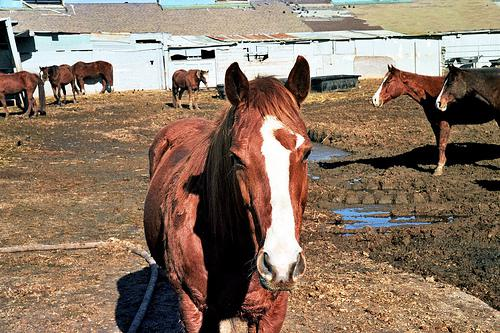Question: what is this a photo of?
Choices:
A. Horses.
B. Cows.
C. Donkeys.
D. Zebras.
Answer with the letter. Answer: A Question: why is there mud?
Choices:
A. It rained.
B. The dirt is wet.
C. There is no grass.
D. The animals scratched the ground.
Answer with the letter. Answer: A Question: who rides a horse?
Choices:
A. A man.
B. A woman.
C. A farmer.
D. A cowboy.
Answer with the letter. Answer: D Question: where was the photo taken?
Choices:
A. Field.
B. Grassland.
C. Pasture.
D. Wheatfield.
Answer with the letter. Answer: C 